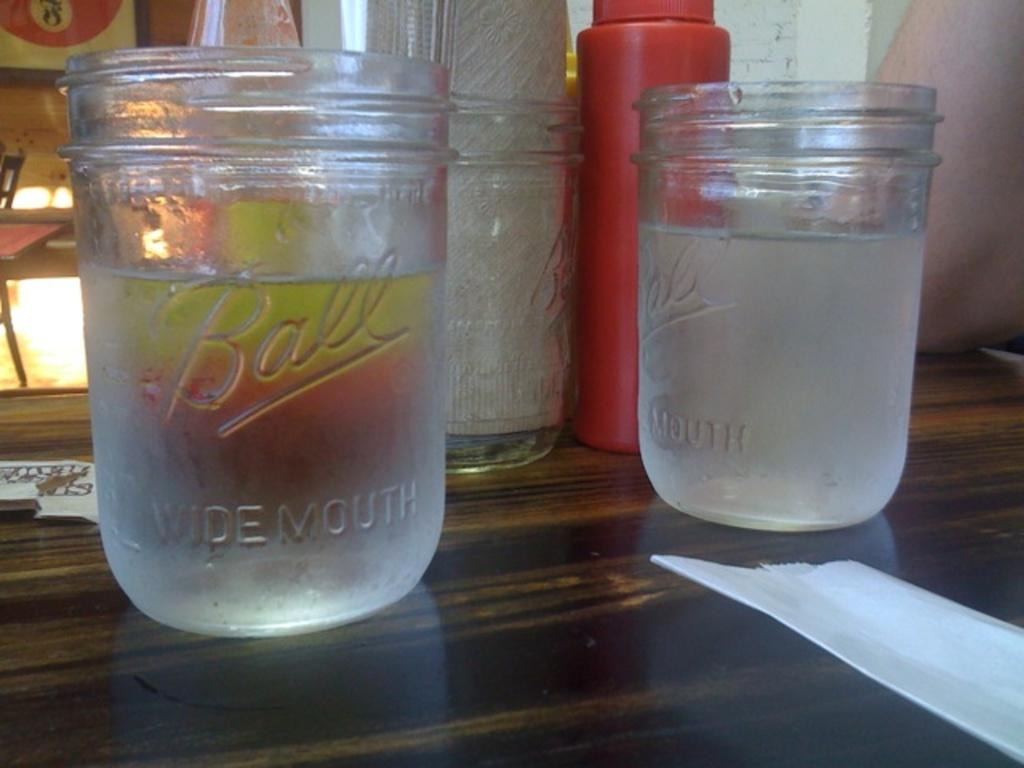Provide a one-sentence caption for the provided image. Ball glasses on the table including two that are filled with water. 